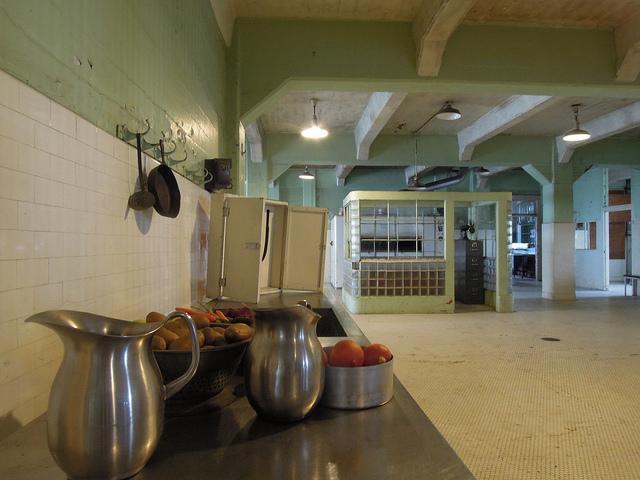Which food provides the most vitamin A?
Indicate the correct response and explain using: 'Answer: answer
Rationale: rationale.'
Options: Yam, potato, onion, carrot. Answer: carrot.
Rationale: Carrots are known to provide many essential vitamins and benefits to the eyes, the most important being vitamin a. 